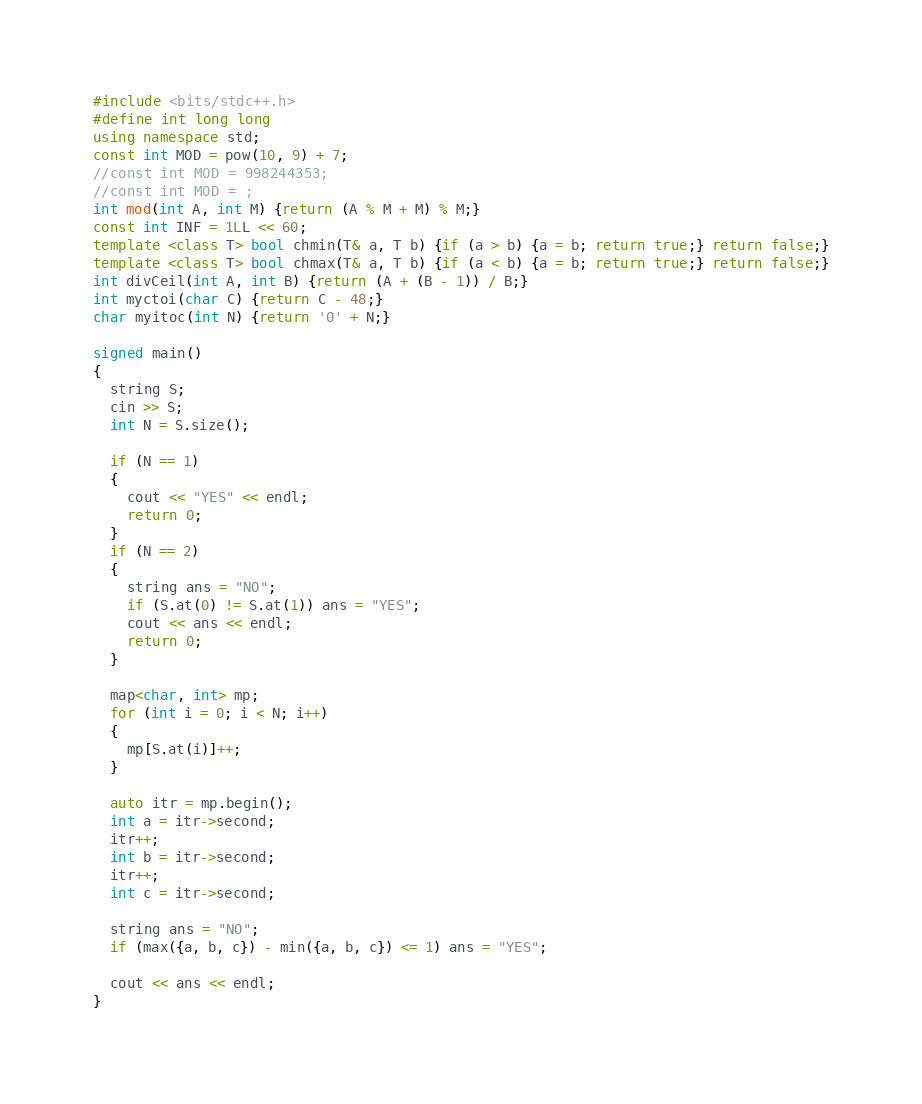Convert code to text. <code><loc_0><loc_0><loc_500><loc_500><_C++_>#include <bits/stdc++.h>
#define int long long
using namespace std;
const int MOD = pow(10, 9) + 7;
//const int MOD = 998244353;
//const int MOD = ;
int mod(int A, int M) {return (A % M + M) % M;}
const int INF = 1LL << 60;
template <class T> bool chmin(T& a, T b) {if (a > b) {a = b; return true;} return false;}
template <class T> bool chmax(T& a, T b) {if (a < b) {a = b; return true;} return false;}
int divCeil(int A, int B) {return (A + (B - 1)) / B;}
int myctoi(char C) {return C - 48;}
char myitoc(int N) {return '0' + N;}

signed main()
{
  string S;
  cin >> S;
  int N = S.size();
  
  if (N == 1)
  {
    cout << "YES" << endl;
    return 0;
  }
  if (N == 2)
  {
    string ans = "NO";
    if (S.at(0) != S.at(1)) ans = "YES";
    cout << ans << endl;
    return 0;
  }

  map<char, int> mp;
  for (int i = 0; i < N; i++)
  {
    mp[S.at(i)]++;
  }
  
  auto itr = mp.begin();
  int a = itr->second;
  itr++;
  int b = itr->second;
  itr++;
  int c = itr->second;
  
  string ans = "NO";
  if (max({a, b, c}) - min({a, b, c}) <= 1) ans = "YES";

  cout << ans << endl;
}</code> 